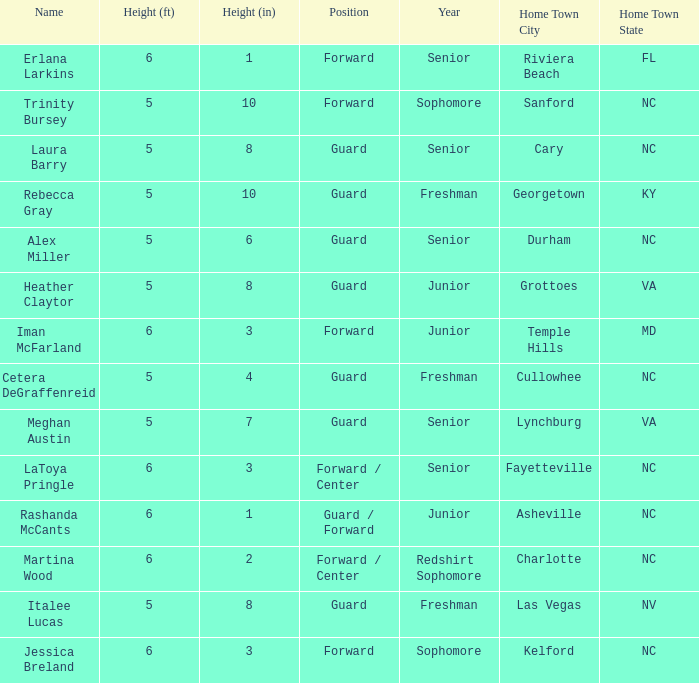Parse the table in full. {'header': ['Name', 'Height (ft)', 'Height (in)', 'Position', 'Year', 'Home Town City', 'Home Town State'], 'rows': [['Erlana Larkins', '6', '1', 'Forward', 'Senior', 'Riviera Beach', 'FL'], ['Trinity Bursey', '5', '10', 'Forward', 'Sophomore', 'Sanford', 'NC'], ['Laura Barry', '5', '8', 'Guard', 'Senior', 'Cary', 'NC'], ['Rebecca Gray', '5', '10', 'Guard', 'Freshman', 'Georgetown', 'KY'], ['Alex Miller', '5', '6', 'Guard', 'Senior', 'Durham', 'NC'], ['Heather Claytor', '5', '8', 'Guard', 'Junior', 'Grottoes', 'VA'], ['Iman McFarland', '6', '3', 'Forward', 'Junior', 'Temple Hills', 'MD'], ['Cetera DeGraffenreid', '5', '4', 'Guard', 'Freshman', 'Cullowhee', 'NC'], ['Meghan Austin', '5', '7', 'Guard', 'Senior', 'Lynchburg', 'VA'], ['LaToya Pringle', '6', '3', 'Forward / Center', 'Senior', 'Fayetteville', 'NC'], ['Rashanda McCants', '6', '1', 'Guard / Forward', 'Junior', 'Asheville', 'NC'], ['Martina Wood', '6', '2', 'Forward / Center', 'Redshirt Sophomore', 'Charlotte', 'NC'], ['Italee Lucas', '5', '8', 'Guard', 'Freshman', 'Las Vegas', 'NV'], ['Jessica Breland', '6', '3', 'Forward', 'Sophomore', 'Kelford', 'NC']]} In what year of school is the forward Iman McFarland? Junior. 